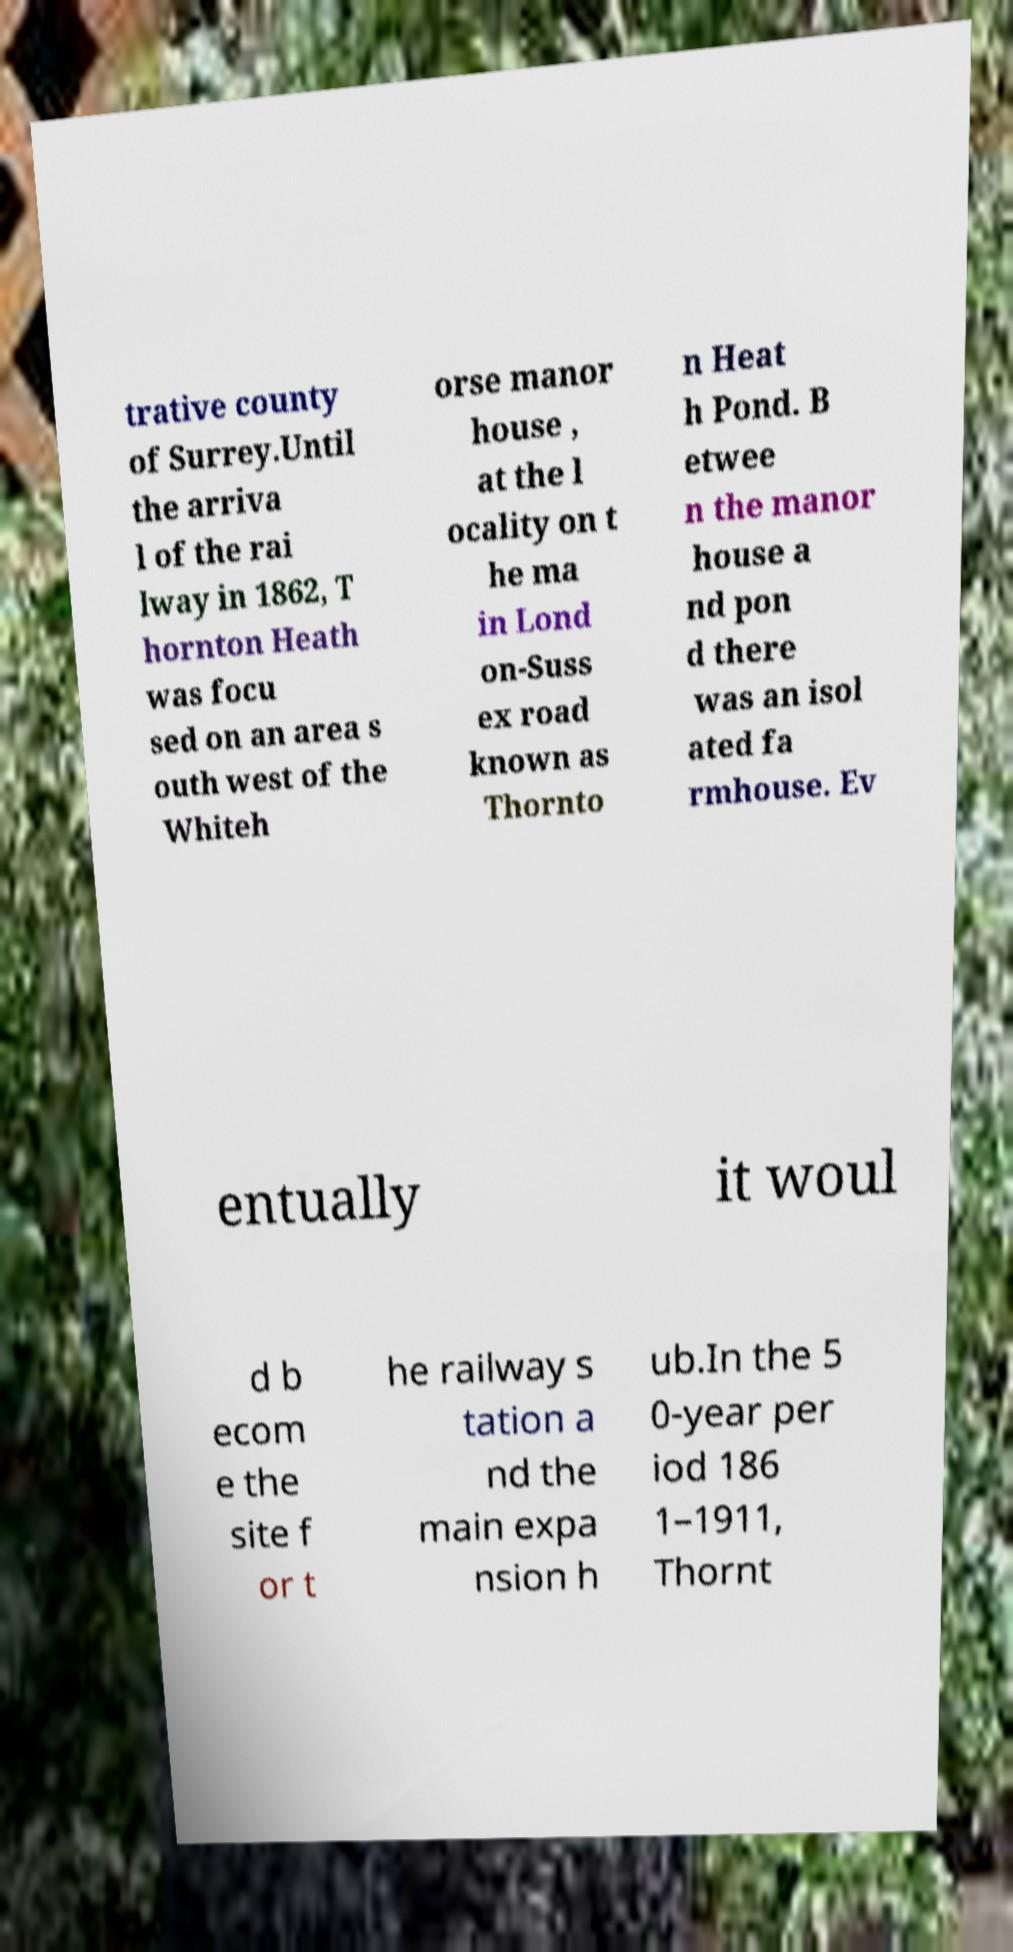Please read and relay the text visible in this image. What does it say? trative county of Surrey.Until the arriva l of the rai lway in 1862, T hornton Heath was focu sed on an area s outh west of the Whiteh orse manor house , at the l ocality on t he ma in Lond on-Suss ex road known as Thornto n Heat h Pond. B etwee n the manor house a nd pon d there was an isol ated fa rmhouse. Ev entually it woul d b ecom e the site f or t he railway s tation a nd the main expa nsion h ub.In the 5 0-year per iod 186 1–1911, Thornt 